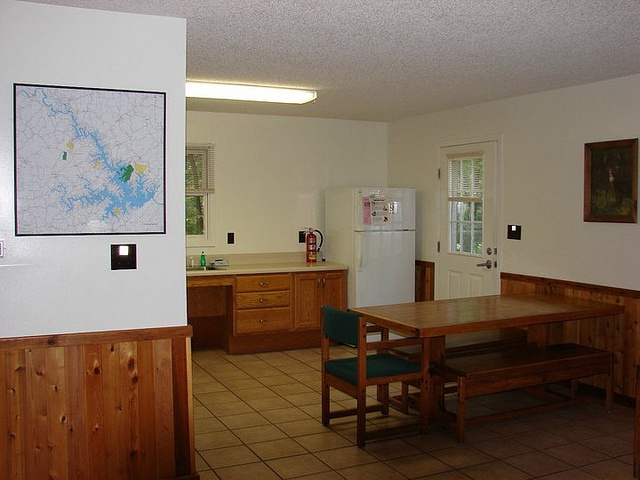Describe the objects in this image and their specific colors. I can see bench in black, maroon, and darkgray tones, chair in darkgray, black, maroon, and gray tones, dining table in darkgray, maroon, black, and gray tones, refrigerator in darkgray and gray tones, and bench in black, maroon, and darkgray tones in this image. 